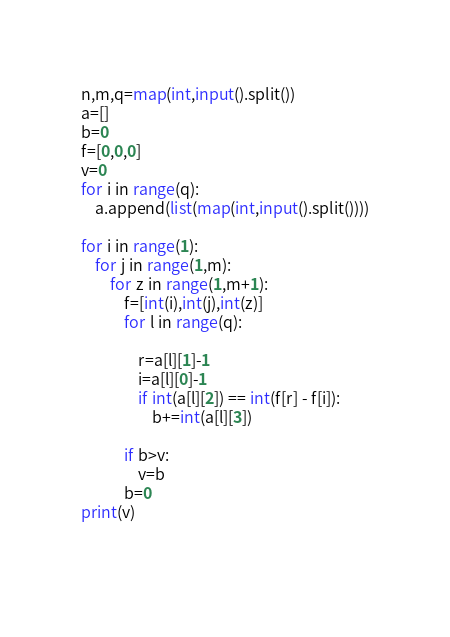<code> <loc_0><loc_0><loc_500><loc_500><_Python_>n,m,q=map(int,input().split())
a=[]
b=0
f=[0,0,0]
v=0
for i in range(q):
    a.append(list(map(int,input().split())))

for i in range(1):
    for j in range(1,m):
        for z in range(1,m+1):
            f=[int(i),int(j),int(z)]
            for l in range(q):
                
                r=a[l][1]-1
                i=a[l][0]-1
                if int(a[l][2]) == int(f[r] - f[i]):
                    b+=int(a[l][3])
            
            if b>v:
                v=b
            b=0
print(v)
            
                
</code> 